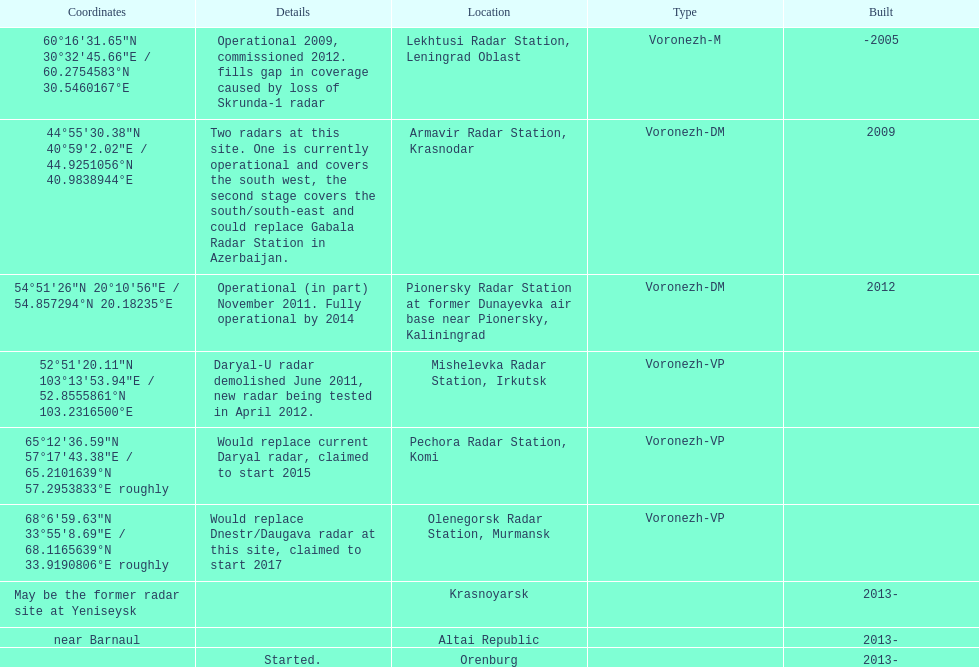Which voronezh radar has already started? Orenburg. Which radar would replace dnestr/daugava? Olenegorsk Radar Station, Murmansk. Which radar started in 2015? Pechora Radar Station, Komi. 